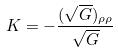Convert formula to latex. <formula><loc_0><loc_0><loc_500><loc_500>K = - \frac { ( \sqrt { G } ) _ { \rho \rho } } { \sqrt { G } }</formula> 